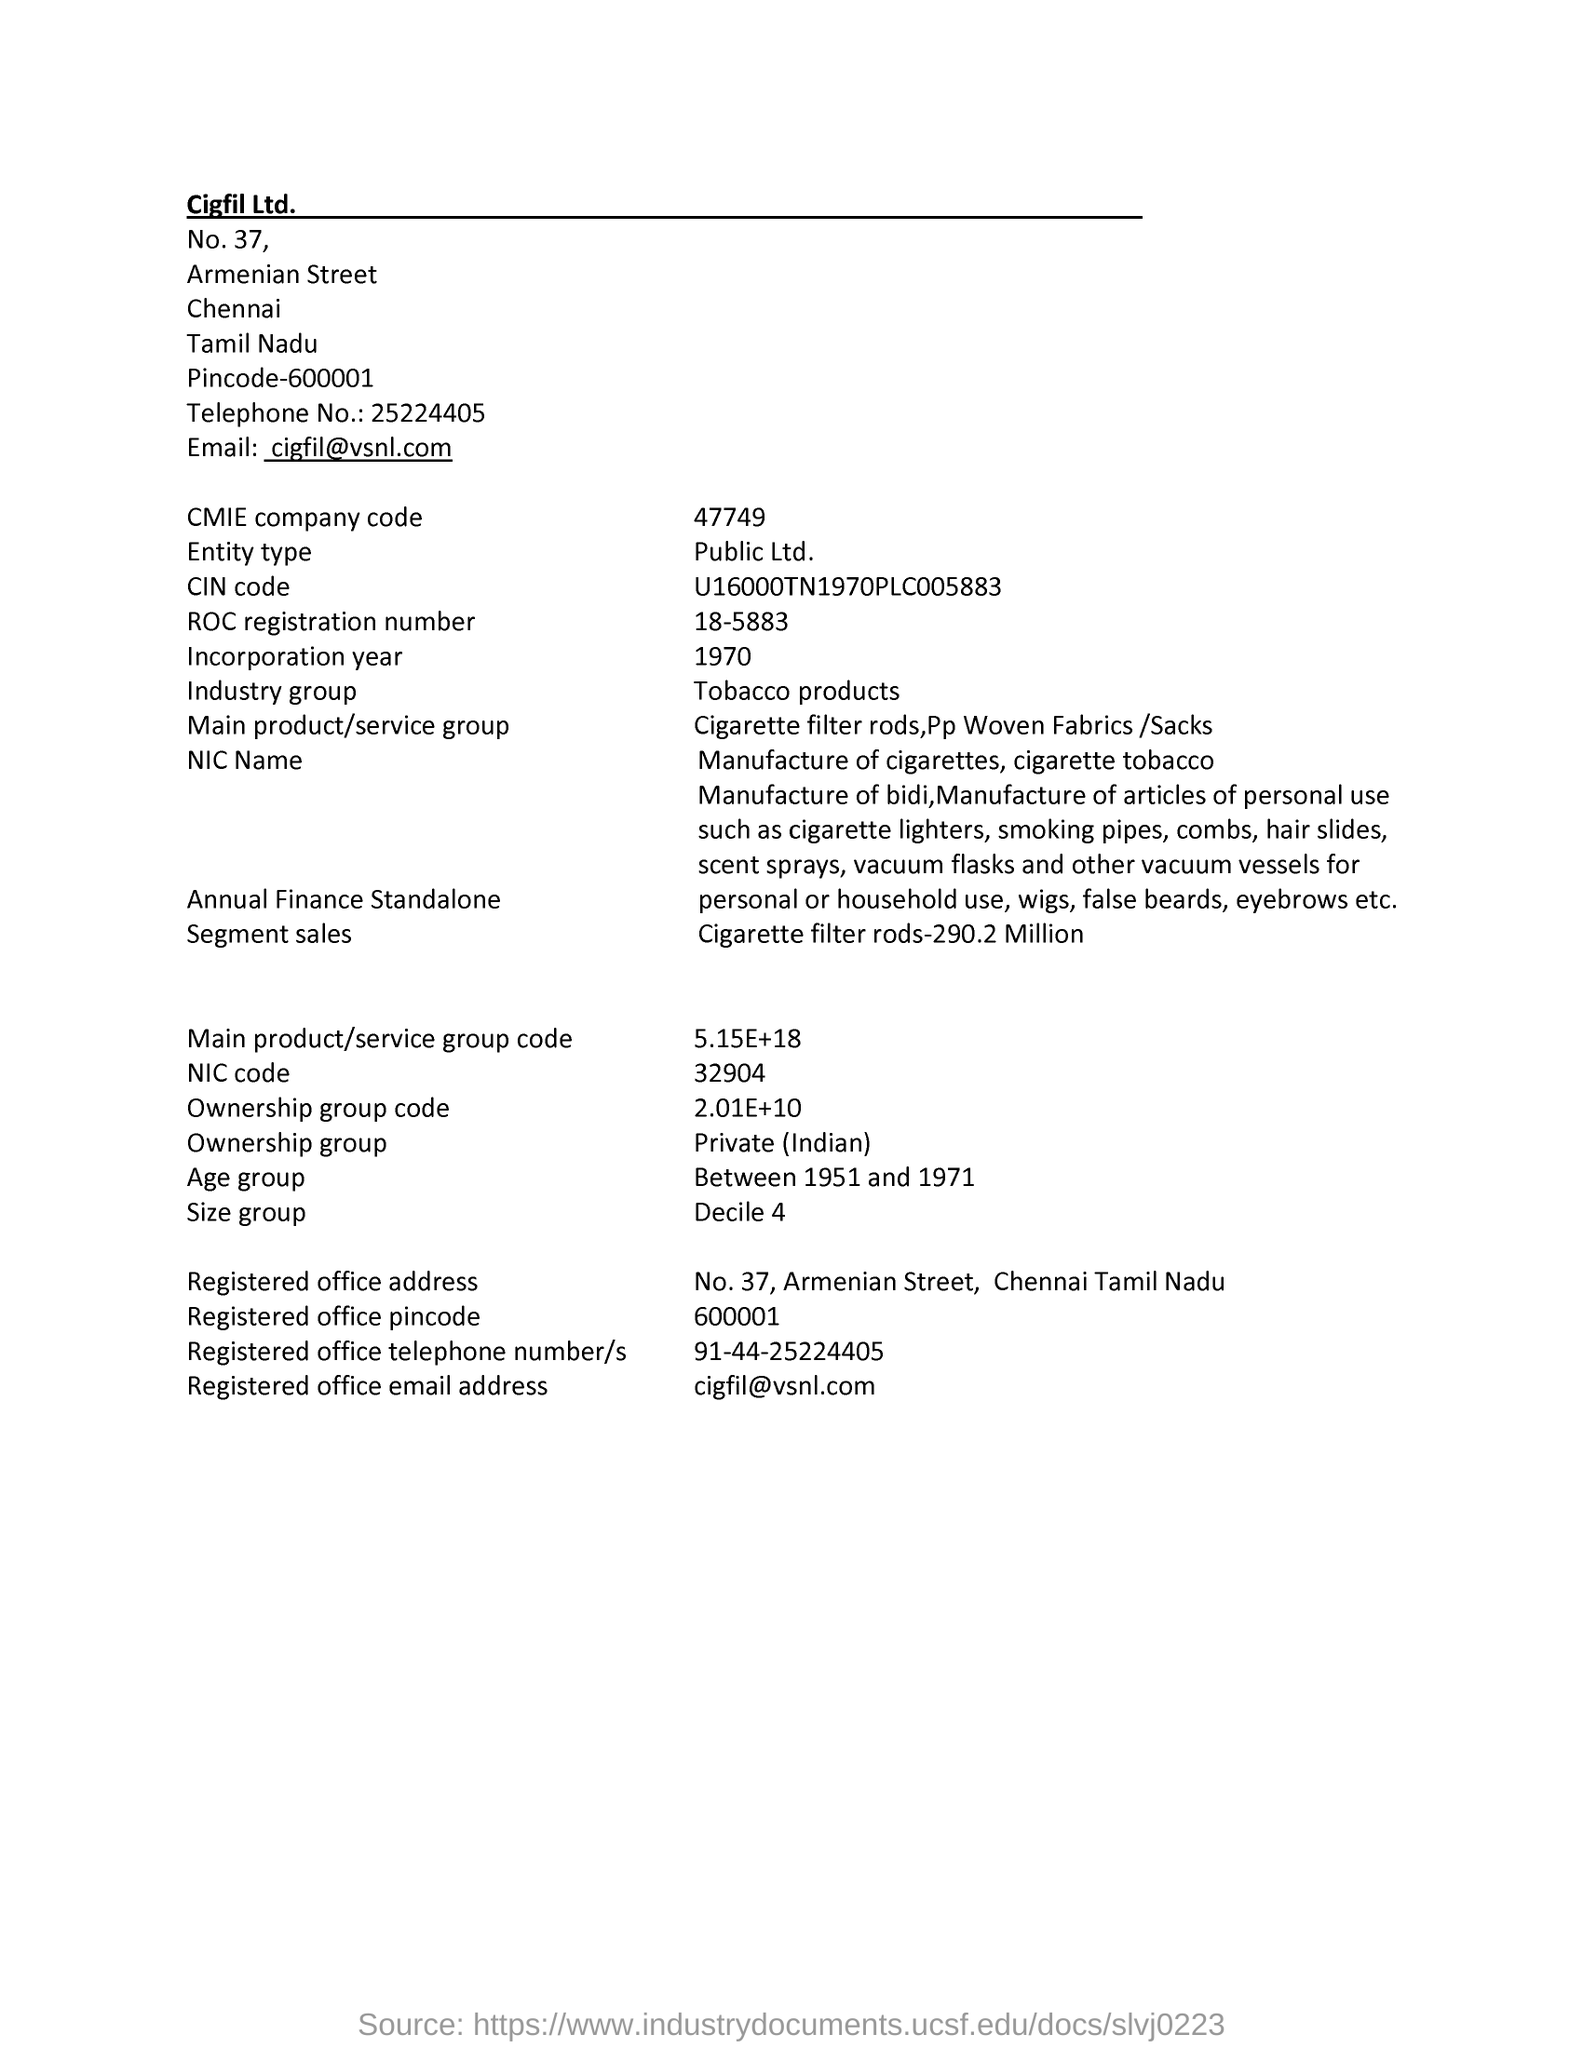What is the CMIE company code given in the document?
Your answer should be very brief. 47749. What is the Entity type mentioned in the document?
Your answer should be very brief. Public ltd. What is the ROC registration number given in the document?
Keep it short and to the point. 18-5883. What is the incorporation year given in the document?
Provide a short and direct response. 1970. What is the Industry Group as per the document?
Offer a terse response. Tobacco Products. What is the NIC Code given in the document?
Give a very brief answer. 32904. Which Age group is mentioned in this document?
Offer a very short reply. Between 1951 and 1971. 